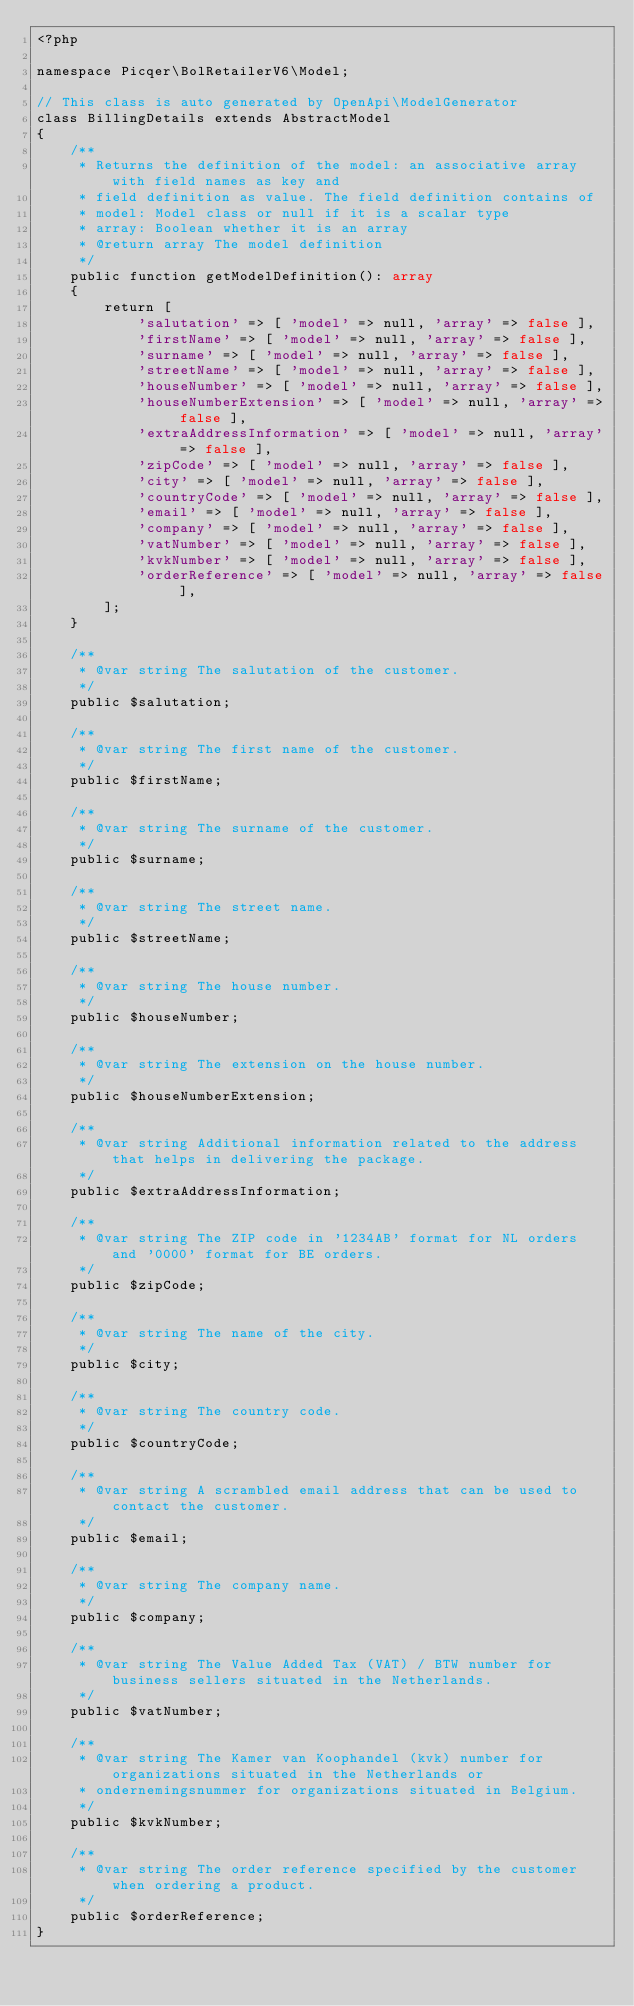<code> <loc_0><loc_0><loc_500><loc_500><_PHP_><?php

namespace Picqer\BolRetailerV6\Model;

// This class is auto generated by OpenApi\ModelGenerator
class BillingDetails extends AbstractModel
{
    /**
     * Returns the definition of the model: an associative array with field names as key and
     * field definition as value. The field definition contains of
     * model: Model class or null if it is a scalar type
     * array: Boolean whether it is an array
     * @return array The model definition
     */
    public function getModelDefinition(): array
    {
        return [
            'salutation' => [ 'model' => null, 'array' => false ],
            'firstName' => [ 'model' => null, 'array' => false ],
            'surname' => [ 'model' => null, 'array' => false ],
            'streetName' => [ 'model' => null, 'array' => false ],
            'houseNumber' => [ 'model' => null, 'array' => false ],
            'houseNumberExtension' => [ 'model' => null, 'array' => false ],
            'extraAddressInformation' => [ 'model' => null, 'array' => false ],
            'zipCode' => [ 'model' => null, 'array' => false ],
            'city' => [ 'model' => null, 'array' => false ],
            'countryCode' => [ 'model' => null, 'array' => false ],
            'email' => [ 'model' => null, 'array' => false ],
            'company' => [ 'model' => null, 'array' => false ],
            'vatNumber' => [ 'model' => null, 'array' => false ],
            'kvkNumber' => [ 'model' => null, 'array' => false ],
            'orderReference' => [ 'model' => null, 'array' => false ],
        ];
    }

    /**
     * @var string The salutation of the customer.
     */
    public $salutation;

    /**
     * @var string The first name of the customer.
     */
    public $firstName;

    /**
     * @var string The surname of the customer.
     */
    public $surname;

    /**
     * @var string The street name.
     */
    public $streetName;

    /**
     * @var string The house number.
     */
    public $houseNumber;

    /**
     * @var string The extension on the house number.
     */
    public $houseNumberExtension;

    /**
     * @var string Additional information related to the address that helps in delivering the package.
     */
    public $extraAddressInformation;

    /**
     * @var string The ZIP code in '1234AB' format for NL orders and '0000' format for BE orders.
     */
    public $zipCode;

    /**
     * @var string The name of the city.
     */
    public $city;

    /**
     * @var string The country code.
     */
    public $countryCode;

    /**
     * @var string A scrambled email address that can be used to contact the customer.
     */
    public $email;

    /**
     * @var string The company name.
     */
    public $company;

    /**
     * @var string The Value Added Tax (VAT) / BTW number for business sellers situated in the Netherlands.
     */
    public $vatNumber;

    /**
     * @var string The Kamer van Koophandel (kvk) number for organizations situated in the Netherlands or
     * ondernemingsnummer for organizations situated in Belgium.
     */
    public $kvkNumber;

    /**
     * @var string The order reference specified by the customer when ordering a product.
     */
    public $orderReference;
}
</code> 